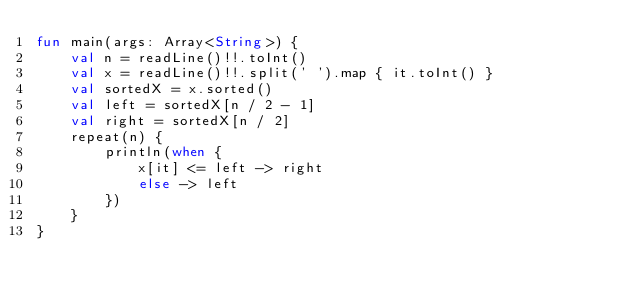<code> <loc_0><loc_0><loc_500><loc_500><_Kotlin_>fun main(args: Array<String>) {
    val n = readLine()!!.toInt()
    val x = readLine()!!.split(' ').map { it.toInt() }
    val sortedX = x.sorted()
    val left = sortedX[n / 2 - 1]
    val right = sortedX[n / 2]
    repeat(n) {
        println(when {
            x[it] <= left -> right
            else -> left
        })
    }
}</code> 